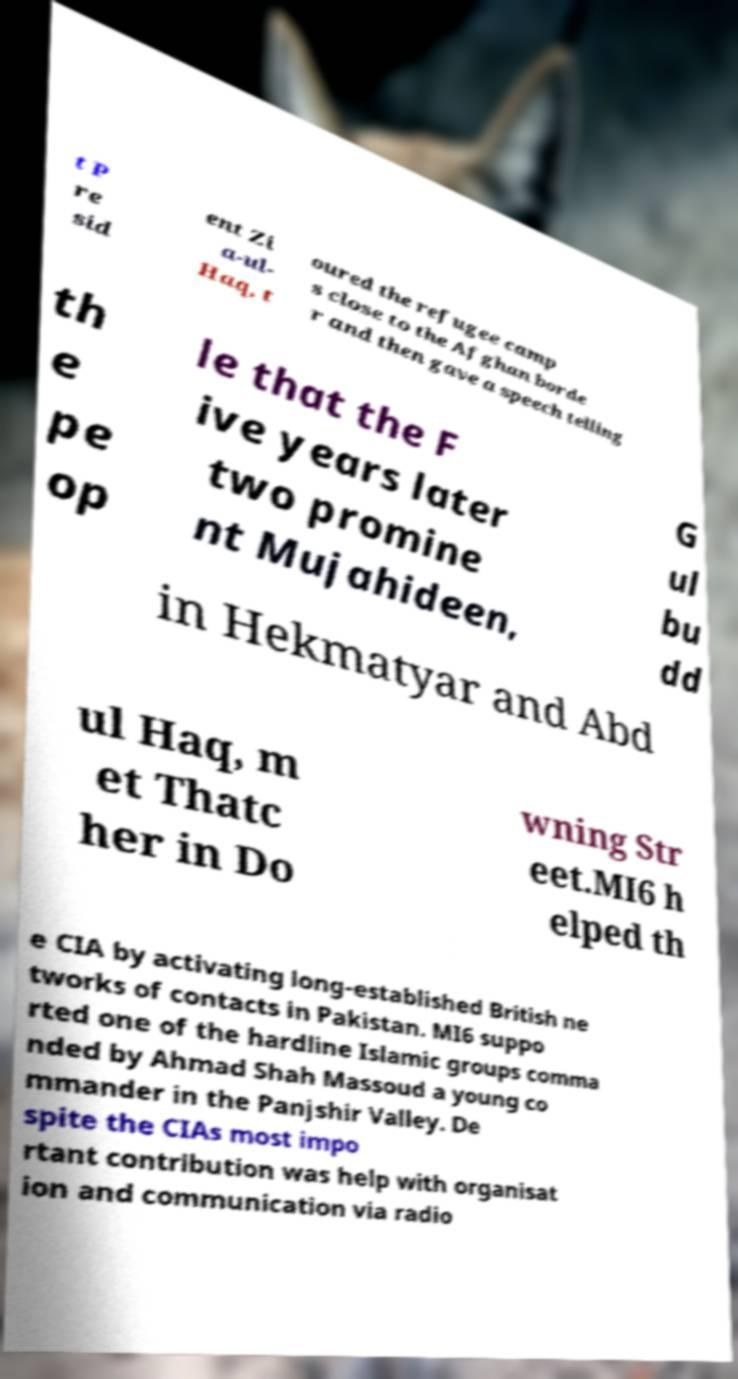Please read and relay the text visible in this image. What does it say? t P re sid ent Zi a-ul- Haq, t oured the refugee camp s close to the Afghan borde r and then gave a speech telling th e pe op le that the F ive years later two promine nt Mujahideen, G ul bu dd in Hekmatyar and Abd ul Haq, m et Thatc her in Do wning Str eet.MI6 h elped th e CIA by activating long-established British ne tworks of contacts in Pakistan. MI6 suppo rted one of the hardline Islamic groups comma nded by Ahmad Shah Massoud a young co mmander in the Panjshir Valley. De spite the CIAs most impo rtant contribution was help with organisat ion and communication via radio 